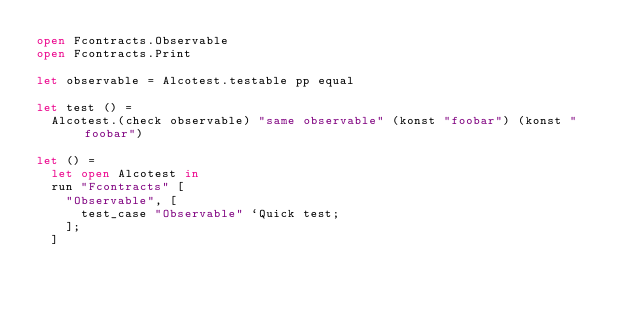<code> <loc_0><loc_0><loc_500><loc_500><_OCaml_>open Fcontracts.Observable
open Fcontracts.Print

let observable = Alcotest.testable pp equal

let test () =
  Alcotest.(check observable) "same observable" (konst "foobar") (konst "foobar")

let () =
  let open Alcotest in
  run "Fcontracts" [
    "Observable", [
      test_case "Observable" `Quick test;
    ];
  ]
</code> 